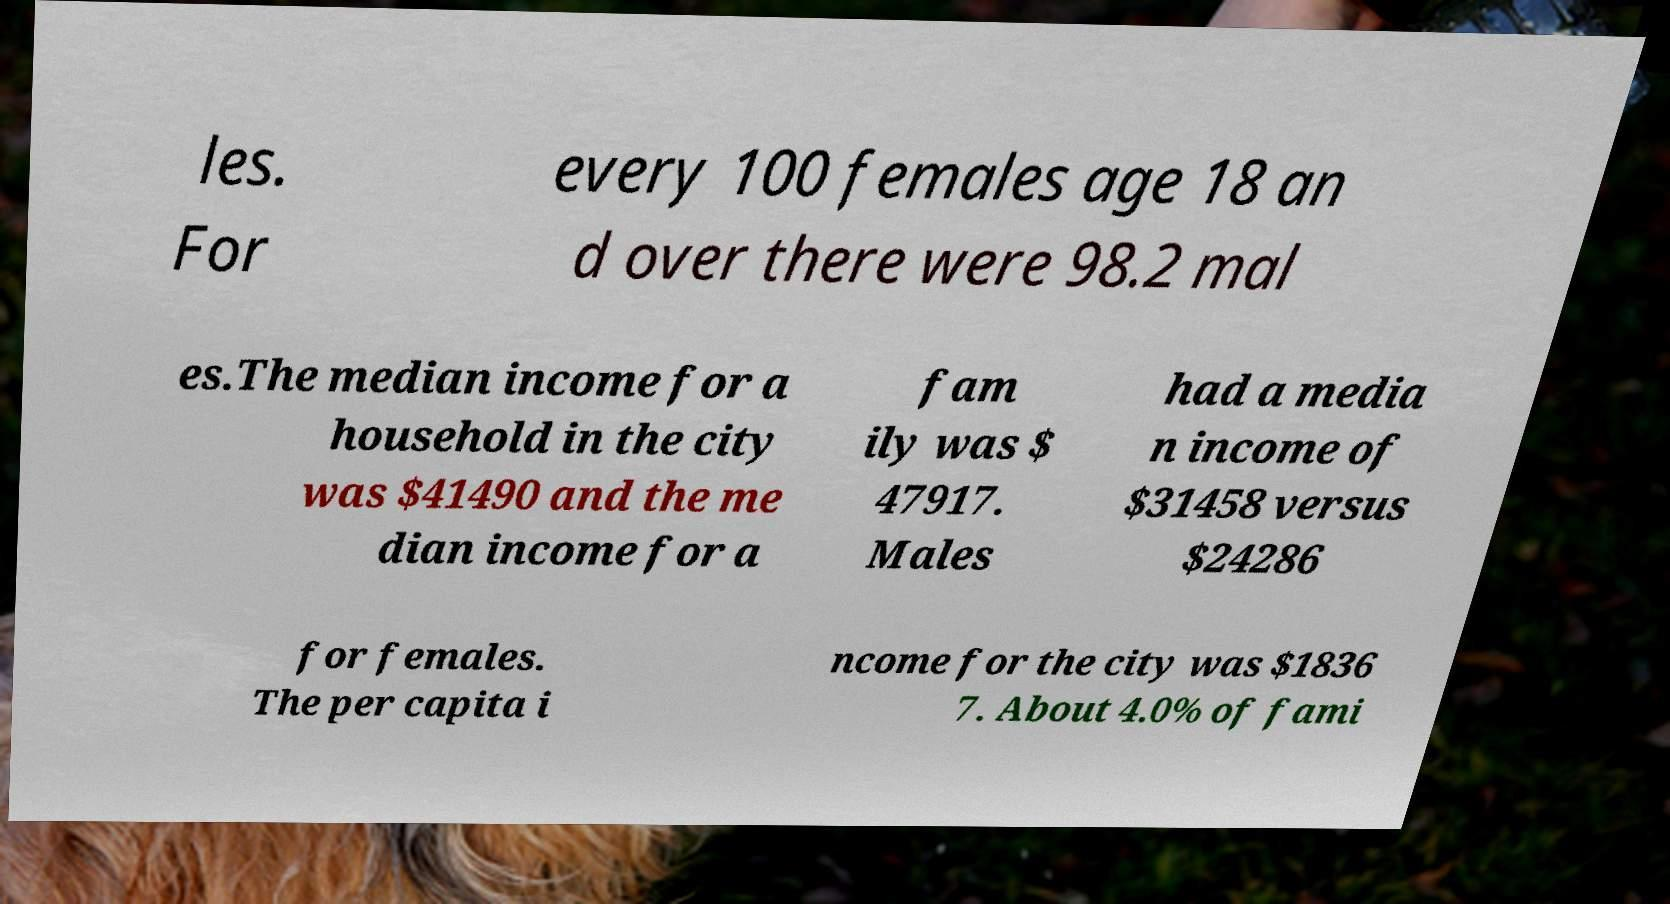Please identify and transcribe the text found in this image. les. For every 100 females age 18 an d over there were 98.2 mal es.The median income for a household in the city was $41490 and the me dian income for a fam ily was $ 47917. Males had a media n income of $31458 versus $24286 for females. The per capita i ncome for the city was $1836 7. About 4.0% of fami 